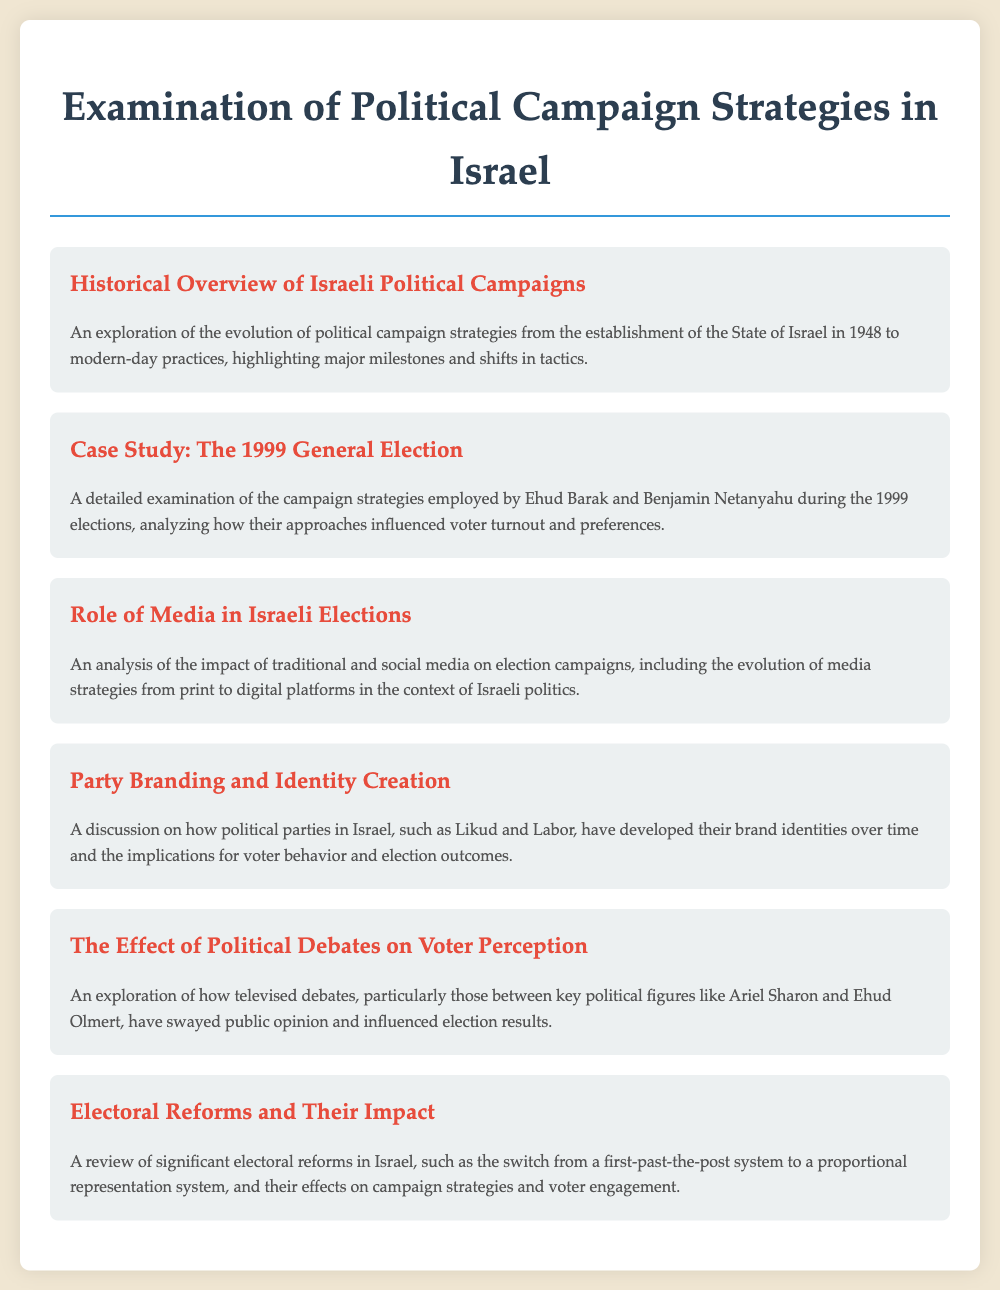what is the title of the document? The title of the document is presented prominently at the top of the page.
Answer: Examination of Political Campaign Strategies in Israel what year did the State of Israel establish? A key milestone in Israeli political history, mentioned in the historical overview.
Answer: 1948 who were the two candidates examined in the 1999 General Election case study? The case study focuses on two prominent politicians during the 1999 elections.
Answer: Ehud Barak and Benjamin Netanyahu what type of media is analyzed in the "Role of Media in Israeli Elections"? The document discusses the evolution of media strategies impacting elections.
Answer: traditional and social media which political parties are mentioned in the "Party Branding and Identity Creation"? The discussion highlights major political parties in relation to branding and identity.
Answer: Likud and Labor what significant electoral reform is referenced in the document? A specific change in the electoral system that affected campaign strategies is noted.
Answer: switch from a first-past-the-post system to a proportional representation system who were key political figures involved in televised debates? The exploration of televised debates in the document identifies significant political figures.
Answer: Ariel Sharon and Ehud Olmert 